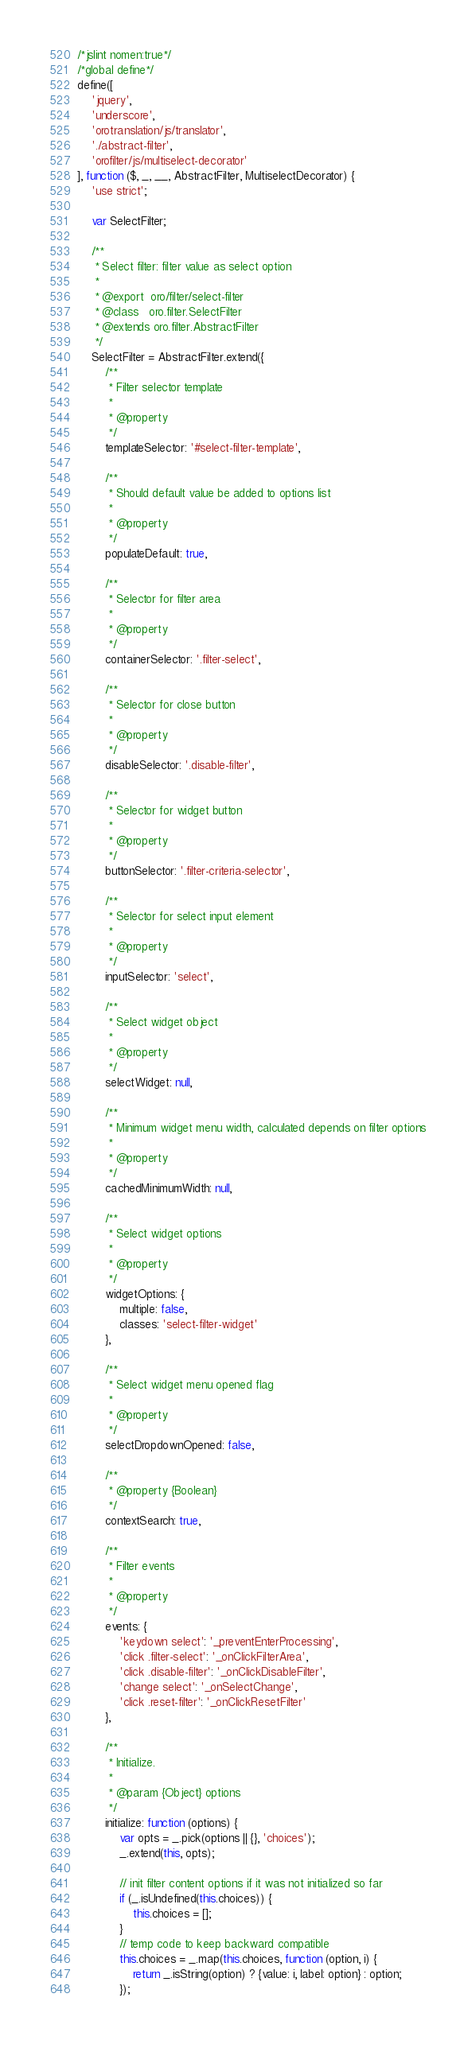Convert code to text. <code><loc_0><loc_0><loc_500><loc_500><_JavaScript_>/*jslint nomen:true*/
/*global define*/
define([
    'jquery',
    'underscore',
    'orotranslation/js/translator',
    './abstract-filter',
    'orofilter/js/multiselect-decorator'
], function ($, _, __, AbstractFilter, MultiselectDecorator) {
    'use strict';

    var SelectFilter;

    /**
     * Select filter: filter value as select option
     *
     * @export  oro/filter/select-filter
     * @class   oro.filter.SelectFilter
     * @extends oro.filter.AbstractFilter
     */
    SelectFilter = AbstractFilter.extend({
        /**
         * Filter selector template
         *
         * @property
         */
        templateSelector: '#select-filter-template',

        /**
         * Should default value be added to options list
         *
         * @property
         */
        populateDefault: true,

        /**
         * Selector for filter area
         *
         * @property
         */
        containerSelector: '.filter-select',

        /**
         * Selector for close button
         *
         * @property
         */
        disableSelector: '.disable-filter',

        /**
         * Selector for widget button
         *
         * @property
         */
        buttonSelector: '.filter-criteria-selector',

        /**
         * Selector for select input element
         *
         * @property
         */
        inputSelector: 'select',

        /**
         * Select widget object
         *
         * @property
         */
        selectWidget: null,

        /**
         * Minimum widget menu width, calculated depends on filter options
         *
         * @property
         */
        cachedMinimumWidth: null,

        /**
         * Select widget options
         *
         * @property
         */
        widgetOptions: {
            multiple: false,
            classes: 'select-filter-widget'
        },

        /**
         * Select widget menu opened flag
         *
         * @property
         */
        selectDropdownOpened: false,

        /**
         * @property {Boolean}
         */
        contextSearch: true,

        /**
         * Filter events
         *
         * @property
         */
        events: {
            'keydown select': '_preventEnterProcessing',
            'click .filter-select': '_onClickFilterArea',
            'click .disable-filter': '_onClickDisableFilter',
            'change select': '_onSelectChange',
            'click .reset-filter': '_onClickResetFilter'
        },

        /**
         * Initialize.
         *
         * @param {Object} options
         */
        initialize: function (options) {
            var opts = _.pick(options || {}, 'choices');
            _.extend(this, opts);

            // init filter content options if it was not initialized so far
            if (_.isUndefined(this.choices)) {
                this.choices = [];
            }
            // temp code to keep backward compatible
            this.choices = _.map(this.choices, function (option, i) {
                return _.isString(option) ? {value: i, label: option} : option;
            });
</code> 